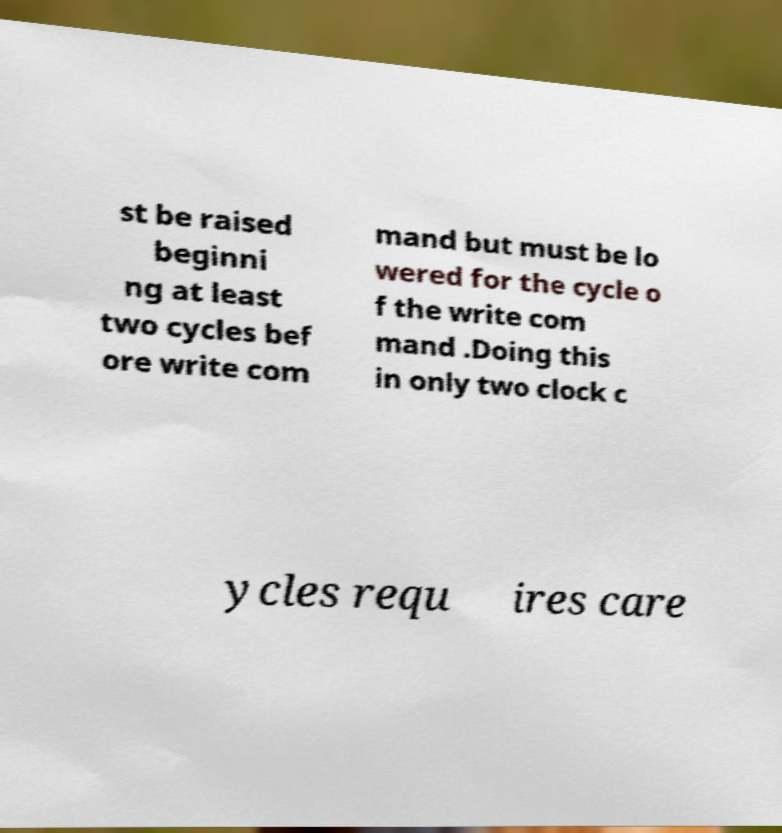There's text embedded in this image that I need extracted. Can you transcribe it verbatim? st be raised beginni ng at least two cycles bef ore write com mand but must be lo wered for the cycle o f the write com mand .Doing this in only two clock c ycles requ ires care 